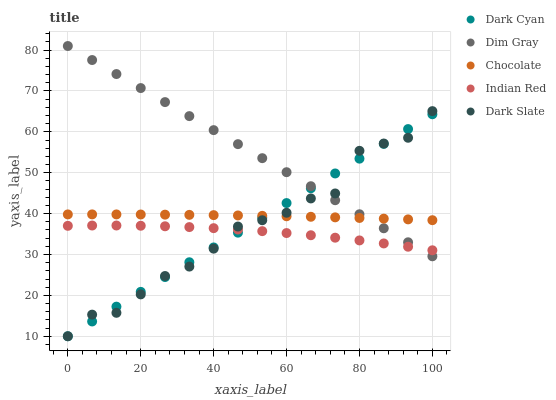Does Indian Red have the minimum area under the curve?
Answer yes or no. Yes. Does Dim Gray have the maximum area under the curve?
Answer yes or no. Yes. Does Dark Slate have the minimum area under the curve?
Answer yes or no. No. Does Dark Slate have the maximum area under the curve?
Answer yes or no. No. Is Dim Gray the smoothest?
Answer yes or no. Yes. Is Dark Slate the roughest?
Answer yes or no. Yes. Is Dark Slate the smoothest?
Answer yes or no. No. Is Dim Gray the roughest?
Answer yes or no. No. Does Dark Cyan have the lowest value?
Answer yes or no. Yes. Does Dim Gray have the lowest value?
Answer yes or no. No. Does Dim Gray have the highest value?
Answer yes or no. Yes. Does Dark Slate have the highest value?
Answer yes or no. No. Is Indian Red less than Chocolate?
Answer yes or no. Yes. Is Chocolate greater than Indian Red?
Answer yes or no. Yes. Does Dark Slate intersect Dim Gray?
Answer yes or no. Yes. Is Dark Slate less than Dim Gray?
Answer yes or no. No. Is Dark Slate greater than Dim Gray?
Answer yes or no. No. Does Indian Red intersect Chocolate?
Answer yes or no. No. 